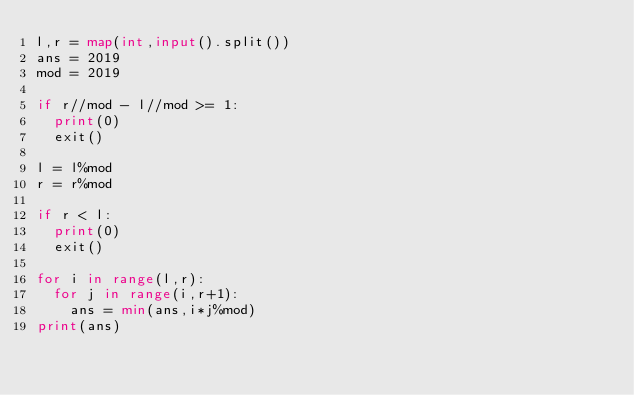<code> <loc_0><loc_0><loc_500><loc_500><_Python_>l,r = map(int,input().split())
ans = 2019
mod = 2019

if r//mod - l//mod >= 1:
  print(0)
  exit()
  
l = l%mod
r = r%mod

if r < l:
  print(0)
  exit()

for i in range(l,r):
  for j in range(i,r+1):
    ans = min(ans,i*j%mod)
print(ans)</code> 